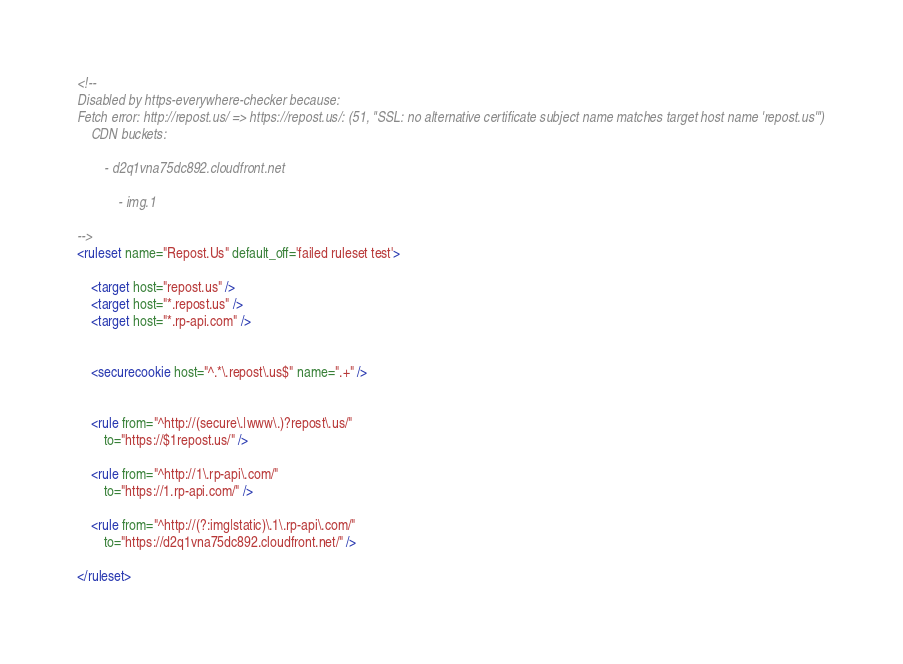<code> <loc_0><loc_0><loc_500><loc_500><_XML_><!--
Disabled by https-everywhere-checker because:
Fetch error: http://repost.us/ => https://repost.us/: (51, "SSL: no alternative certificate subject name matches target host name 'repost.us'")
	CDN buckets:

		- d2q1vna75dc892.cloudfront.net

			- img.1

-->
<ruleset name="Repost.Us" default_off='failed ruleset test'>

	<target host="repost.us" />
	<target host="*.repost.us" />
	<target host="*.rp-api.com" />


	<securecookie host="^.*\.repost\.us$" name=".+" />


	<rule from="^http://(secure\.|www\.)?repost\.us/"
		to="https://$1repost.us/" />

	<rule from="^http://1\.rp-api\.com/"
		to="https://1.rp-api.com/" />

	<rule from="^http://(?:img|static)\.1\.rp-api\.com/"
		to="https://d2q1vna75dc892.cloudfront.net/" />

</ruleset>
</code> 